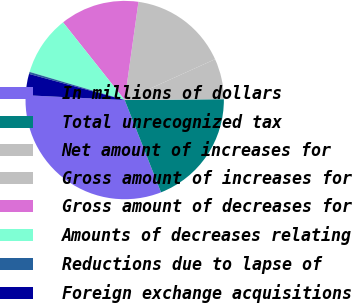Convert chart. <chart><loc_0><loc_0><loc_500><loc_500><pie_chart><fcel>In millions of dollars<fcel>Total unrecognized tax<fcel>Net amount of increases for<fcel>Gross amount of increases for<fcel>Gross amount of decreases for<fcel>Amounts of decreases relating<fcel>Reductions due to lapse of<fcel>Foreign exchange acquisitions<nl><fcel>31.74%<fcel>19.17%<fcel>6.61%<fcel>16.03%<fcel>12.89%<fcel>9.75%<fcel>0.33%<fcel>3.47%<nl></chart> 